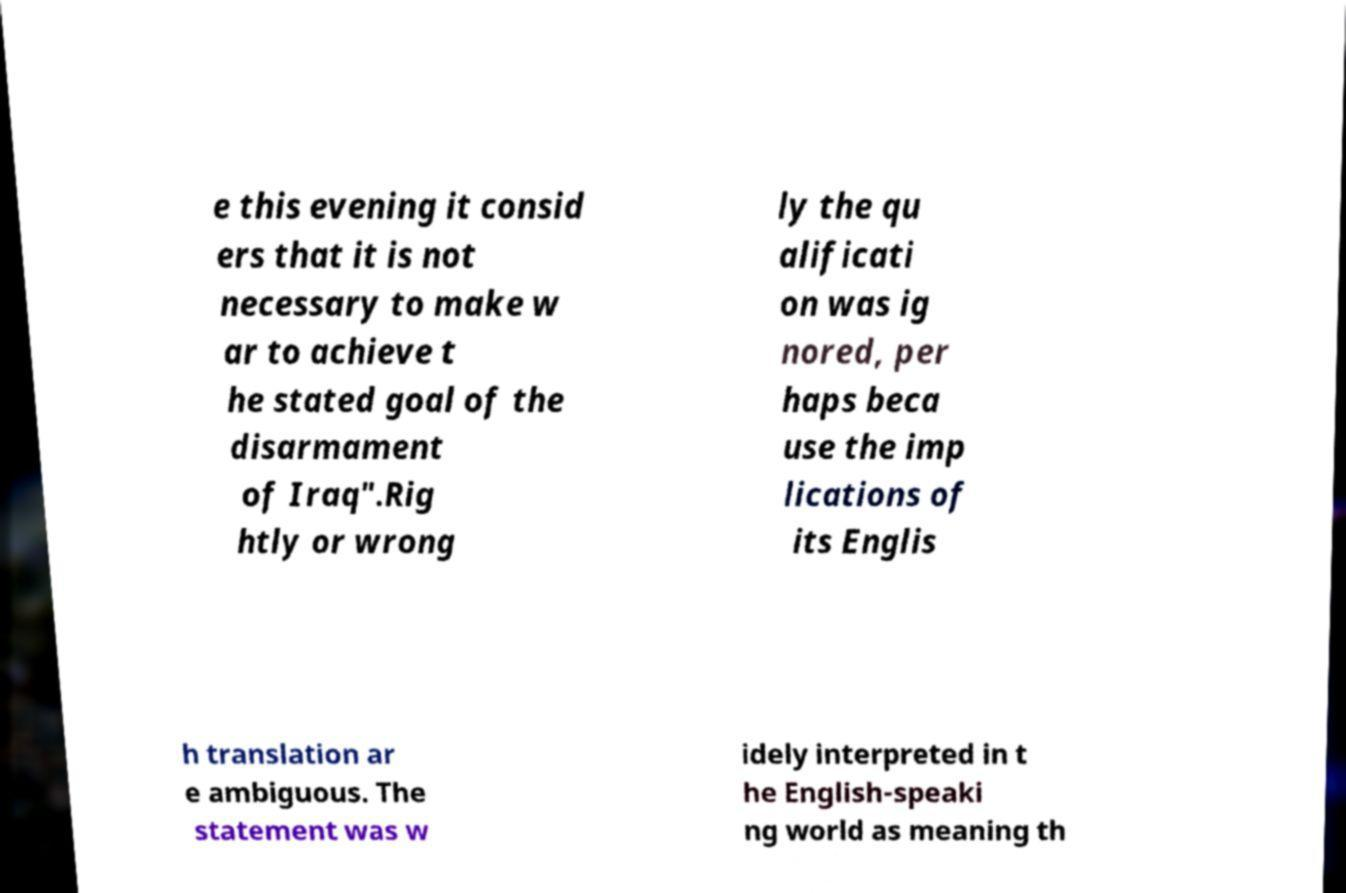Could you assist in decoding the text presented in this image and type it out clearly? e this evening it consid ers that it is not necessary to make w ar to achieve t he stated goal of the disarmament of Iraq".Rig htly or wrong ly the qu alificati on was ig nored, per haps beca use the imp lications of its Englis h translation ar e ambiguous. The statement was w idely interpreted in t he English-speaki ng world as meaning th 